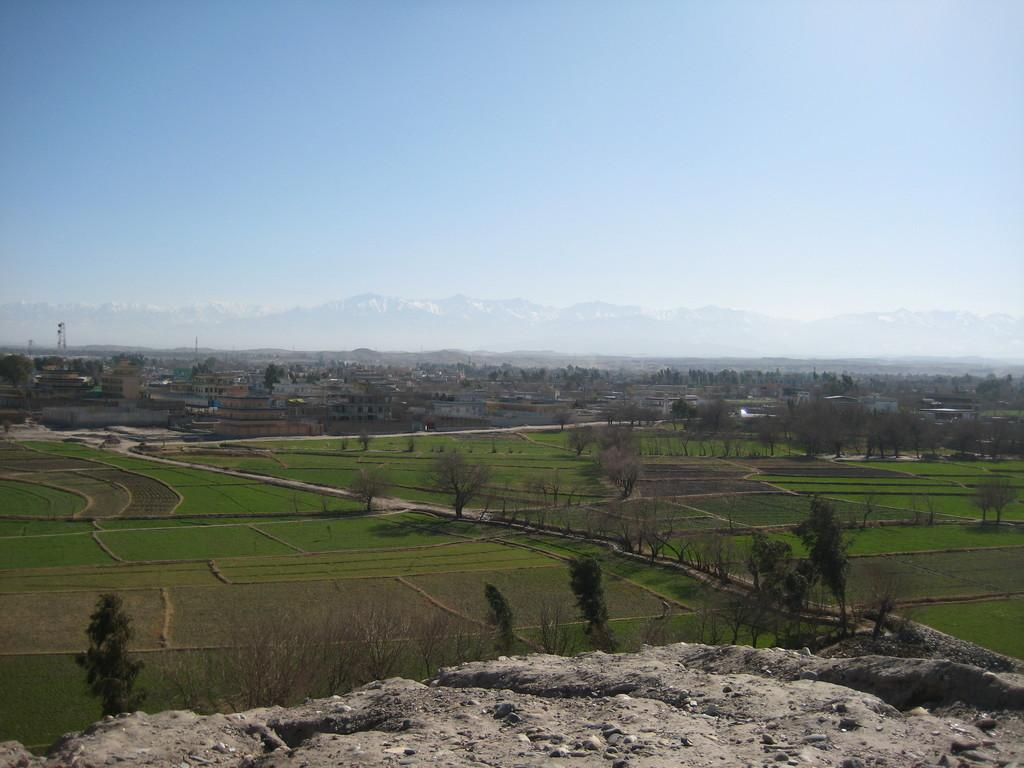What type of structures can be seen in the image? There are buildings in the image. What type of vegetation is present in the image? There are trees in the image. What are the tall, thin objects in the image? There are poles in the image. What type of open space can be seen in the image? There are fields in the image. What type of natural landform is present in the image? There are hills in the image. What is visible at the top of the image? The sky is visible at the top of the image. What type of polish is being applied to the buildings in the image? There is no mention of polish being applied to the buildings in the image. Where is the cemetery located in the image? There is no cemetery present in the image. 